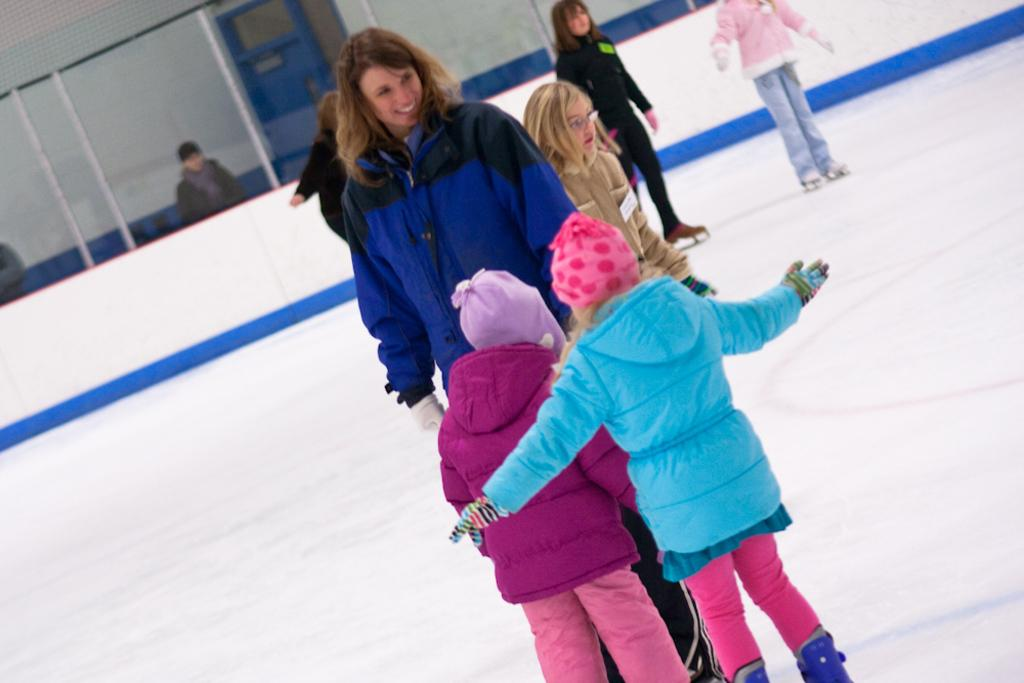What are the people in the foreground of the image doing? The people in the foreground of the image are skating on the floor. What can be seen in the background of the image? In the background of the image, there is a fence, two persons, a door, and a wall. How many people are visible in the image? There are at least three people visible in the image: the group of people in the foreground and the two persons in the background. Can you describe the lighting in the image? The image was likely taken during the day, as there is sufficient natural light to see the details clearly. What type of receipt can be seen in the image? There is no receipt present in the image. How does the loss of balance affect the skaters in the image? There is no indication of any loss of balance among the skaters in the image. 